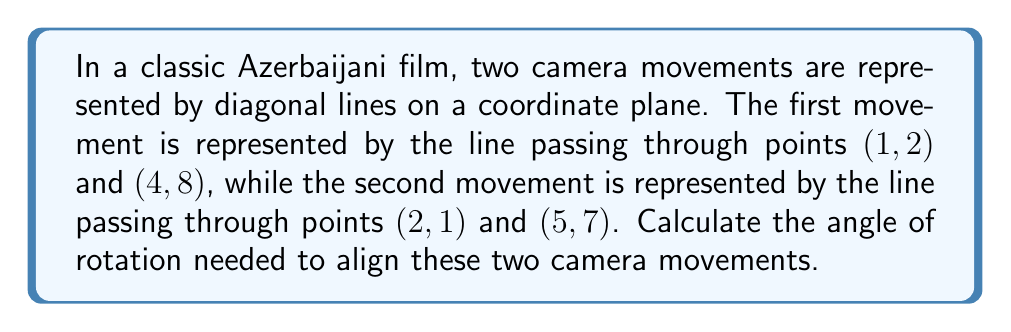Can you answer this question? To find the angle of rotation needed to align the two camera movements, we need to follow these steps:

1. Calculate the slopes of both lines:

For the first line: 
$$m_1 = \frac{y_2 - y_1}{x_2 - x_1} = \frac{8 - 2}{4 - 1} = \frac{6}{3} = 2$$

For the second line:
$$m_2 = \frac{y_2 - y_1}{x_2 - x_1} = \frac{7 - 1}{5 - 2} = \frac{6}{3} = 2$$

2. Calculate the angle between the lines using the formula:

$$\tan \theta = \left|\frac{m_2 - m_1}{1 + m_1m_2}\right|$$

Substituting the values:

$$\tan \theta = \left|\frac{2 - 2}{1 + 2(2)}\right| = \left|\frac{0}{5}\right| = 0$$

3. Take the inverse tangent (arctangent) to find the angle:

$$\theta = \arctan(0) = 0$$

4. Convert the angle from radians to degrees:

$$\theta = 0 \cdot \frac{180°}{\pi} = 0°$$

The angle between the lines is 0°, which means they are already aligned and no rotation is needed.

[asy]
import geometry;

size(200);
draw((-1,-1)--(6,11), arrow=Arrow(TeXHead));
draw((0,-1)--(6,11), arrow=Arrow(TeXHead));
dot((1,2));
dot((4,8));
dot((2,1));
dot((5,7));
label("(1,2)", (1,2), SW);
label("(4,8)", (4,8), NE);
label("(2,1)", (2,1), SE);
label("(5,7)", (5,7), NE);
[/asy]
Answer: The angle of rotation needed to align the two camera movements is $0°$. 